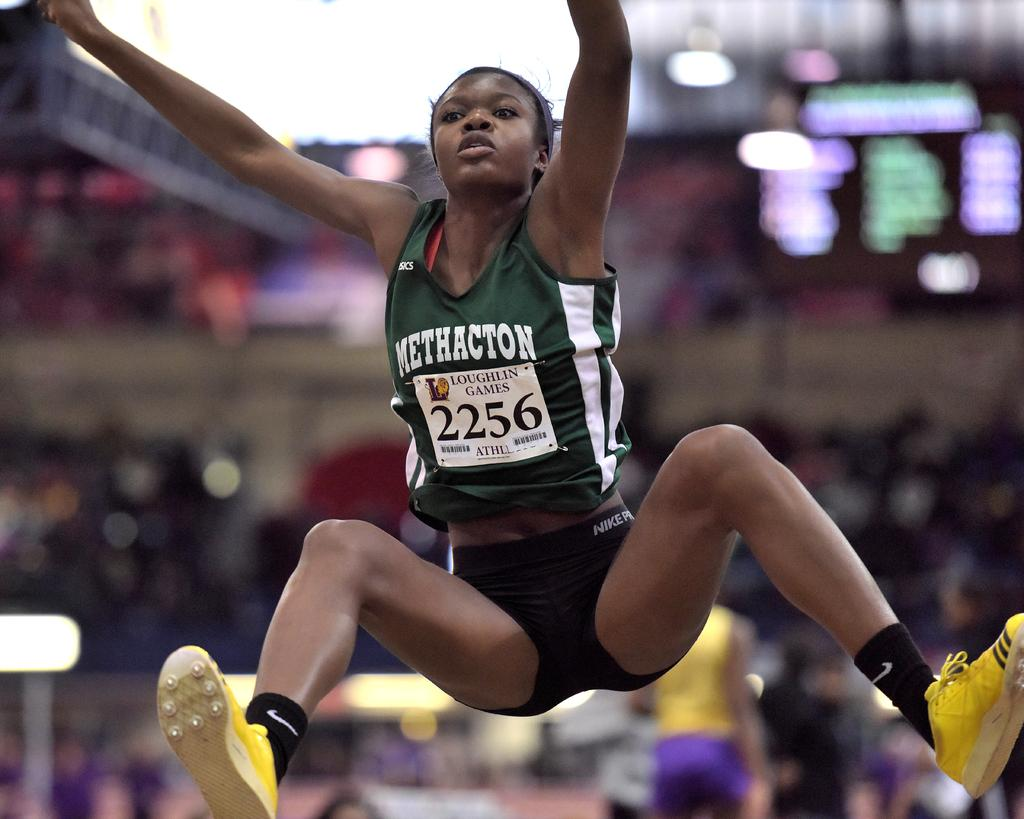<image>
Write a terse but informative summary of the picture. an athlete that has the number 2256 on them 